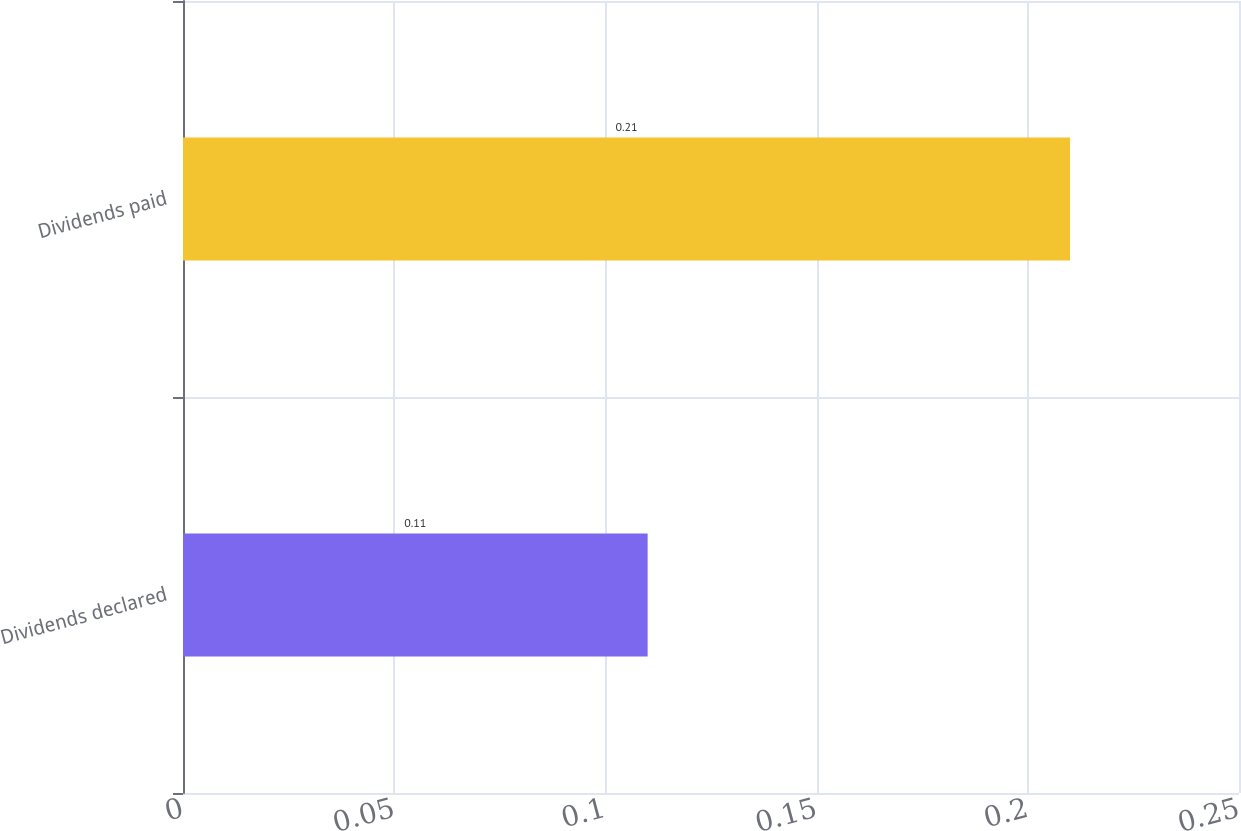<chart> <loc_0><loc_0><loc_500><loc_500><bar_chart><fcel>Dividends declared<fcel>Dividends paid<nl><fcel>0.11<fcel>0.21<nl></chart> 